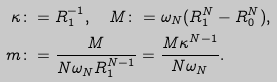<formula> <loc_0><loc_0><loc_500><loc_500>\kappa & \colon = R _ { 1 } ^ { - 1 } , \quad M \colon = \omega _ { N } ( R _ { 1 } ^ { N } - R _ { 0 } ^ { N } ) , \\ m & \colon = \frac { M } { N \omega _ { N } R _ { 1 } ^ { N - 1 } } = \frac { M \kappa ^ { N - 1 } } { N \omega _ { N } } .</formula> 